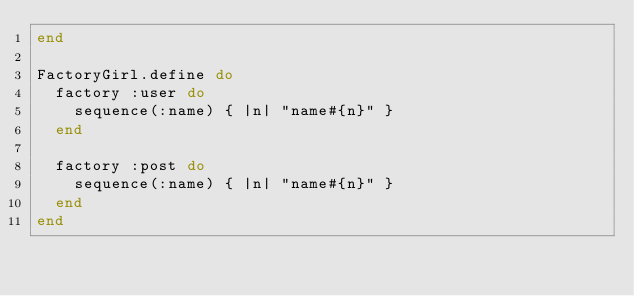Convert code to text. <code><loc_0><loc_0><loc_500><loc_500><_Ruby_>end

FactoryGirl.define do
  factory :user do
    sequence(:name) { |n| "name#{n}" }
  end

  factory :post do
    sequence(:name) { |n| "name#{n}" }
  end
end
</code> 